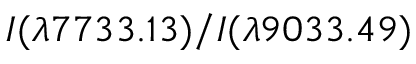Convert formula to latex. <formula><loc_0><loc_0><loc_500><loc_500>I ( \lambda 7 7 3 3 . 1 3 ) / I ( \lambda 9 0 3 3 . 4 9 )</formula> 